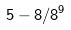Convert formula to latex. <formula><loc_0><loc_0><loc_500><loc_500>5 - 8 / 8 ^ { 9 }</formula> 